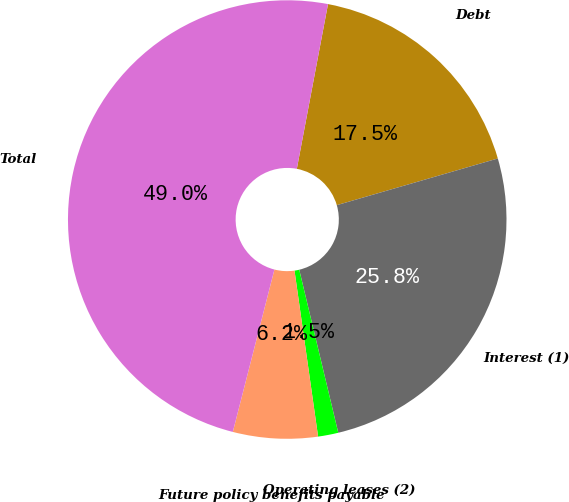Convert chart to OTSL. <chart><loc_0><loc_0><loc_500><loc_500><pie_chart><fcel>Debt<fcel>Interest (1)<fcel>Operating leases (2)<fcel>Future policy benefits payable<fcel>Total<nl><fcel>17.53%<fcel>25.75%<fcel>1.49%<fcel>6.24%<fcel>48.98%<nl></chart> 